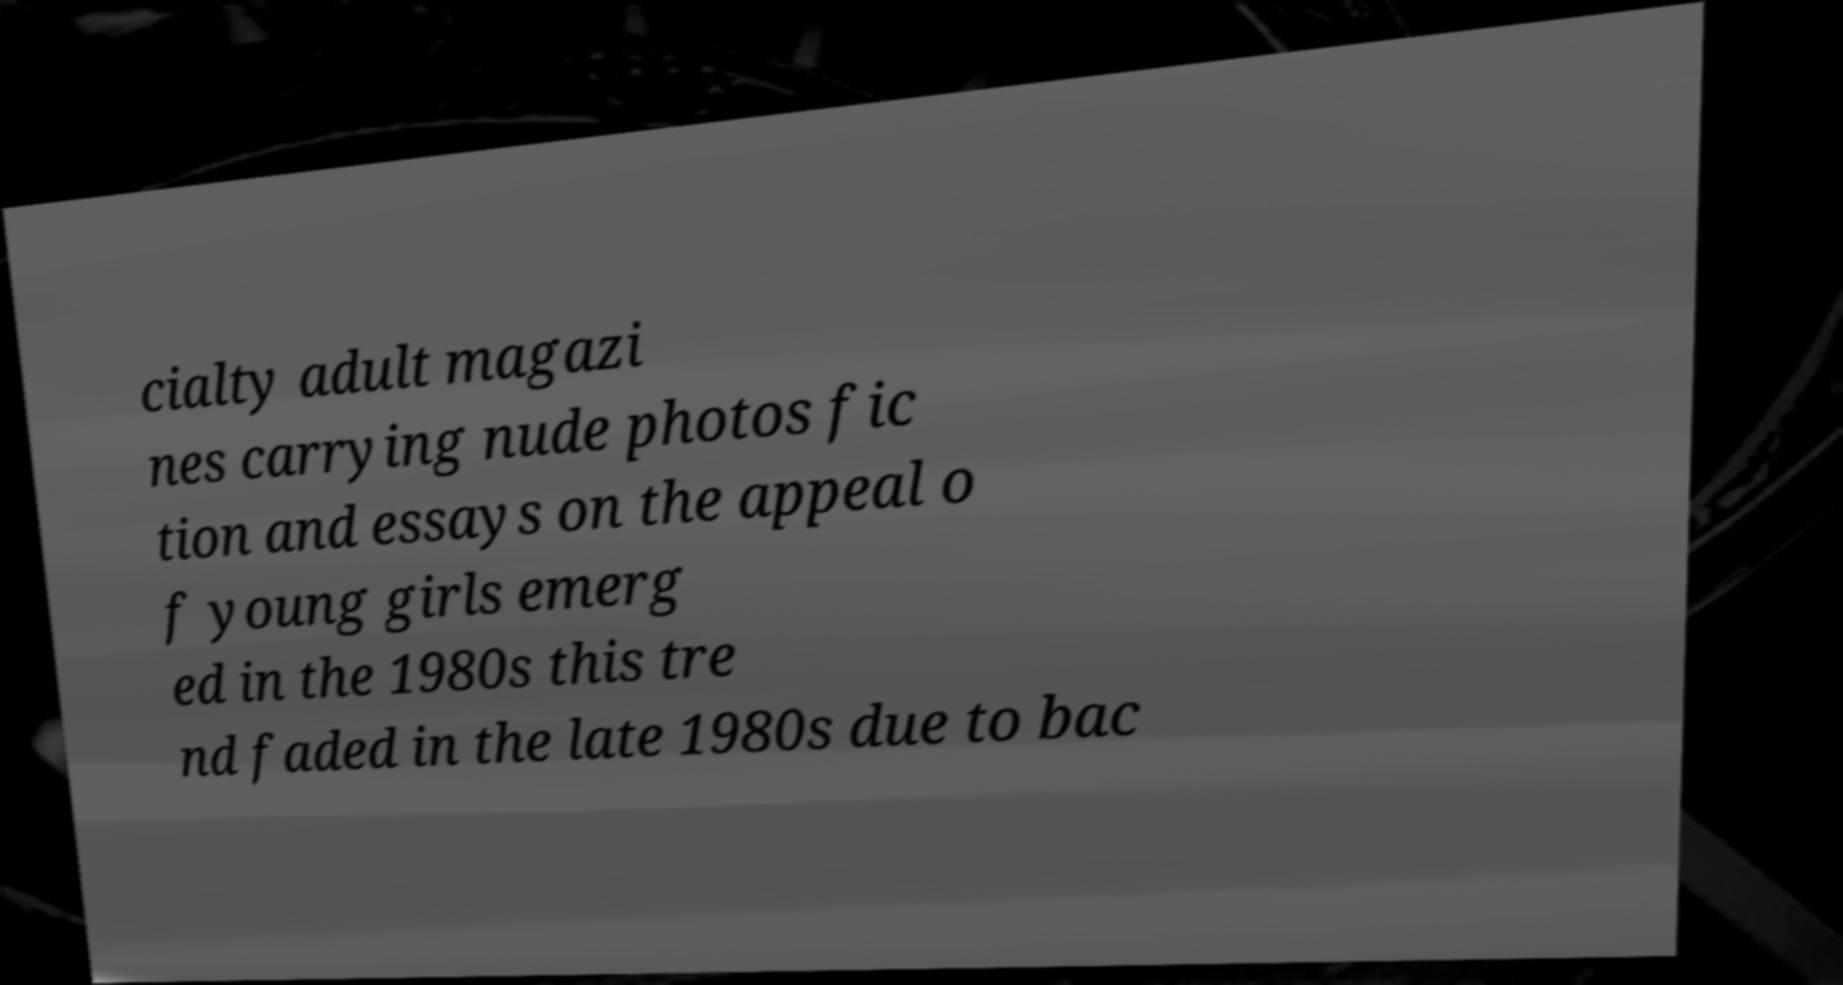I need the written content from this picture converted into text. Can you do that? cialty adult magazi nes carrying nude photos fic tion and essays on the appeal o f young girls emerg ed in the 1980s this tre nd faded in the late 1980s due to bac 